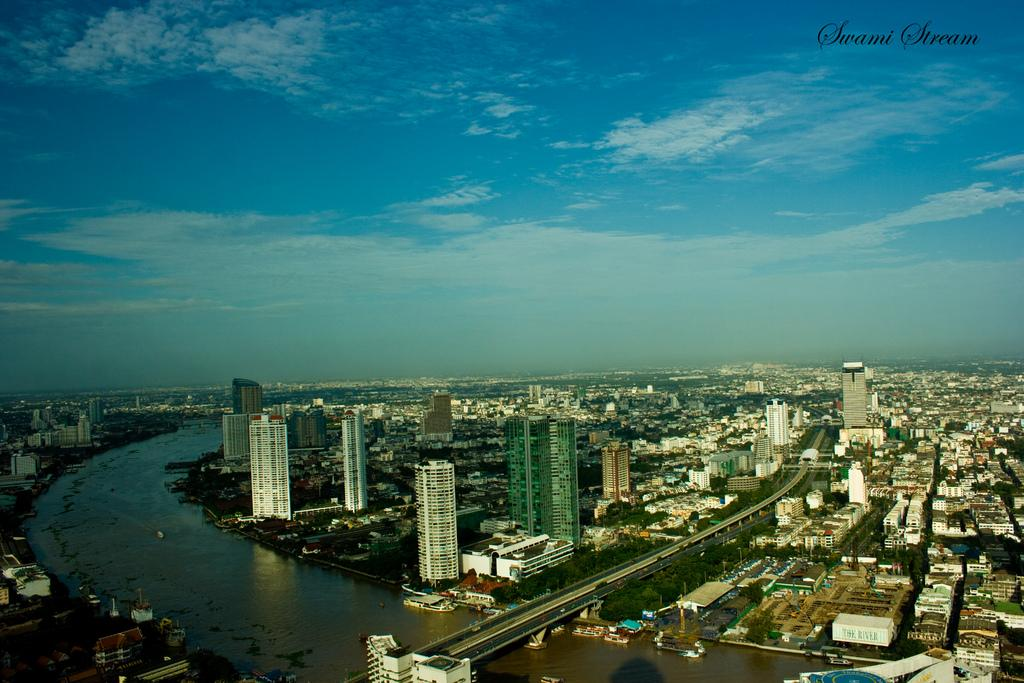What type of structures can be seen in the image? There are buildings in the image. What natural elements are present in the image? There are trees in the image. What type of man-made structure connects two areas in the image? There is a bridge in the image. What type of transportation is visible in the image? There are boats on water in the image. What can be seen in the background of the image? The sky is visible in the background of the image. What atmospheric feature is present in the sky? Clouds are present in the sky. What type of discussion is taking place between the scarecrow and the man in the image? There is no man or scarecrow present in the image; it features buildings, trees, a bridge, boats, and a sky with clouds. 